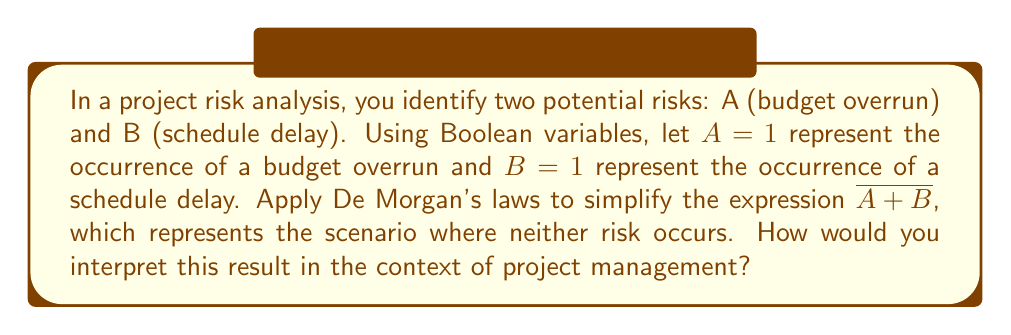Give your solution to this math problem. 1. Start with the given expression: $\overline{A + B}$

2. Apply De Morgan's law: $\overline{A + B} = \overline{A} \cdot \overline{B}$

3. Interpret the result:
   - $\overline{A}$ means "not A", or "no budget overrun"
   - $\overline{B}$ means "not B", or "no schedule delay"
   - $\overline{A} \cdot \overline{B}$ means both conditions must be true simultaneously

4. In project management context:
   - This simplified expression represents the scenario where both risks are successfully mitigated
   - It implies that for the project to be completely successful (in terms of these two risks), both the budget must not be overrun AND the schedule must not be delayed

5. Practical application:
   - This analysis helps the project manager focus on strategies that address both risks simultaneously
   - It emphasizes the importance of integrated risk management rather than treating each risk in isolation
Answer: $\overline{A} \cdot \overline{B}$ (Both budget and schedule targets are met) 